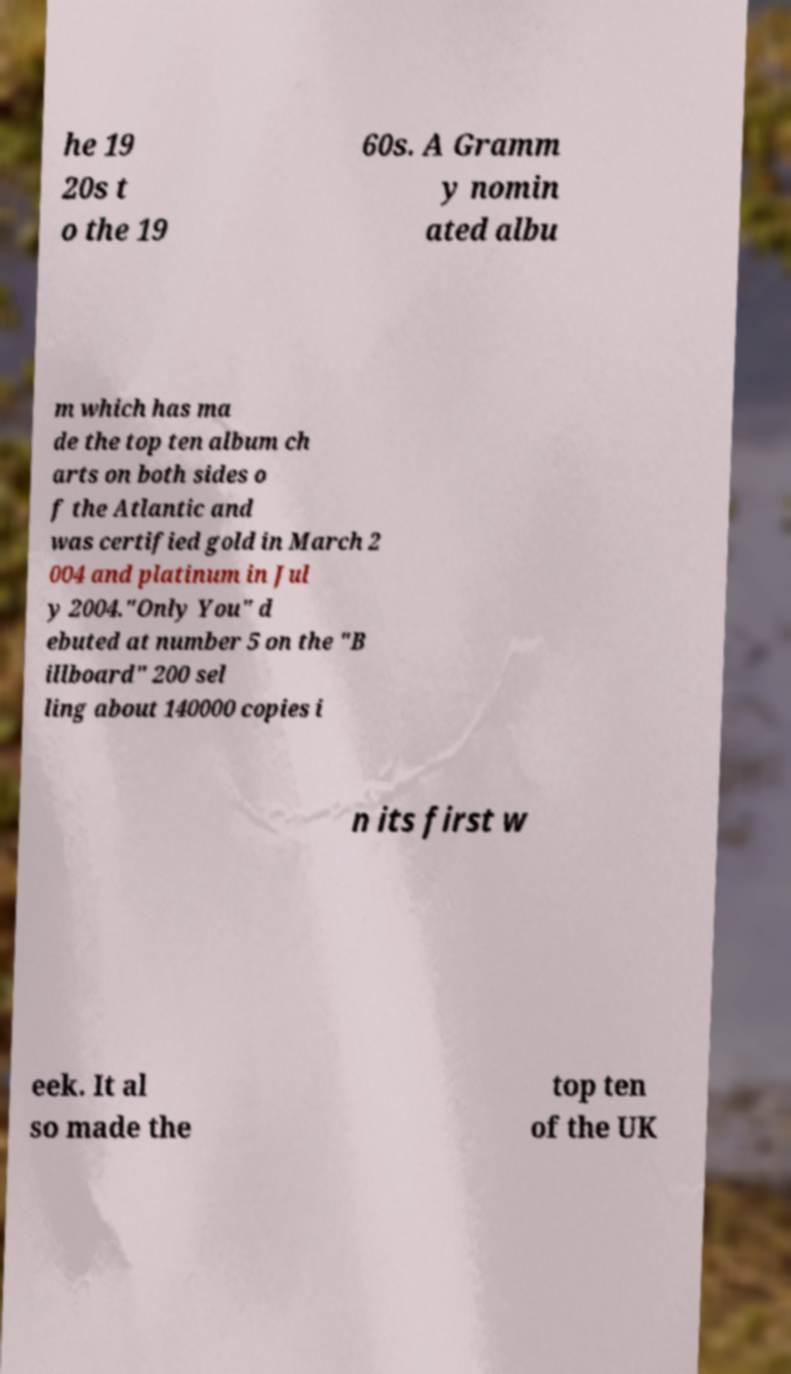Can you accurately transcribe the text from the provided image for me? he 19 20s t o the 19 60s. A Gramm y nomin ated albu m which has ma de the top ten album ch arts on both sides o f the Atlantic and was certified gold in March 2 004 and platinum in Jul y 2004."Only You" d ebuted at number 5 on the "B illboard" 200 sel ling about 140000 copies i n its first w eek. It al so made the top ten of the UK 